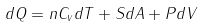Convert formula to latex. <formula><loc_0><loc_0><loc_500><loc_500>d Q = n C _ { v } d T + S d A + P d V</formula> 